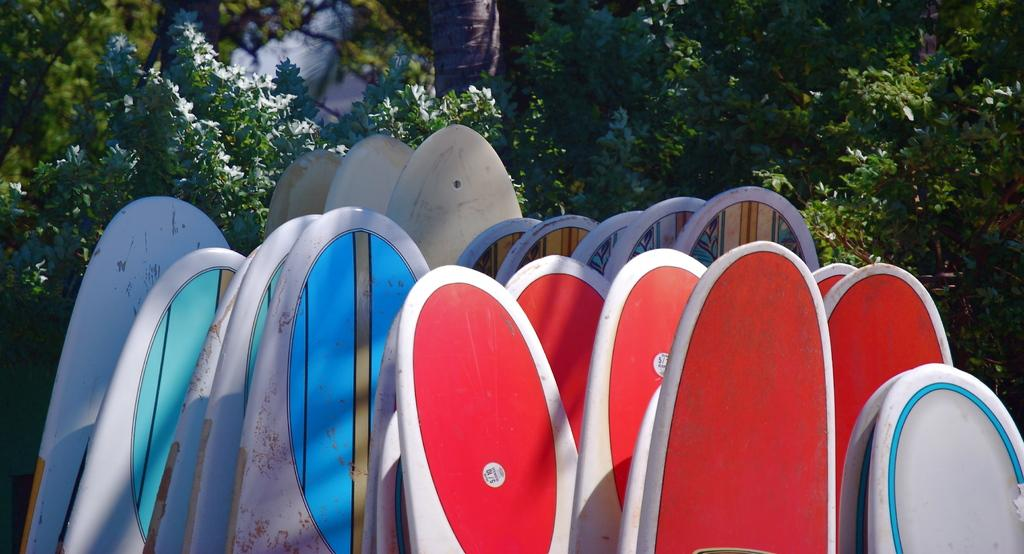What objects are present in the image that are related to surfing? There are different colors of surfing boards in the image. What can be seen in the background of the image? There are plants and trees in the backdrop of the image. What type of toys can be seen on the tray in the image? There is no tray or toys present in the image. 